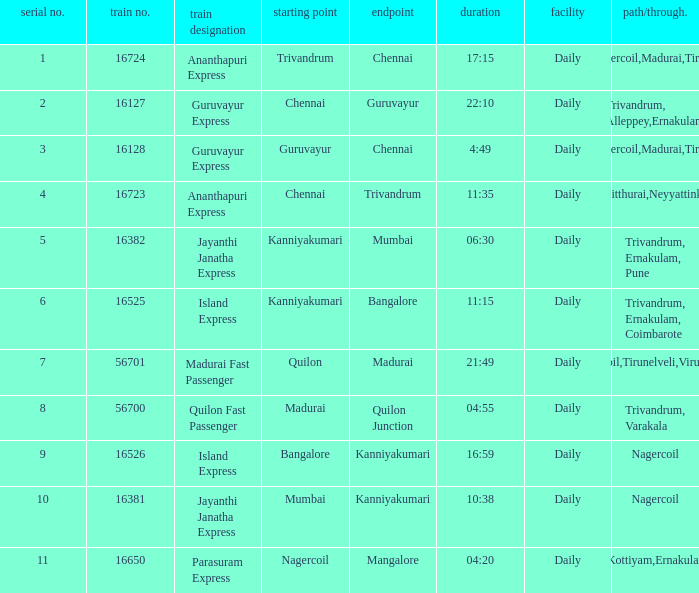What is the destination when the train number is 16526? Kanniyakumari. Parse the table in full. {'header': ['serial no.', 'train no.', 'train designation', 'starting point', 'endpoint', 'duration', 'facility', 'path/through.'], 'rows': [['1', '16724', 'Ananthapuri Express', 'Trivandrum', 'Chennai', '17:15', 'Daily', 'Nagercoil,Madurai,Tiruchi'], ['2', '16127', 'Guruvayur Express', 'Chennai', 'Guruvayur', '22:10', 'Daily', 'Trivandrum, Alleppey,Ernakulam'], ['3', '16128', 'Guruvayur Express', 'Guruvayur', 'Chennai', '4:49', 'Daily', 'Nagercoil,Madurai,Tiruchi'], ['4', '16723', 'Ananthapuri Express', 'Chennai', 'Trivandrum', '11:35', 'Daily', 'Kulitthurai,Neyyattinkara'], ['5', '16382', 'Jayanthi Janatha Express', 'Kanniyakumari', 'Mumbai', '06:30', 'Daily', 'Trivandrum, Ernakulam, Pune'], ['6', '16525', 'Island Express', 'Kanniyakumari', 'Bangalore', '11:15', 'Daily', 'Trivandrum, Ernakulam, Coimbarote'], ['7', '56701', 'Madurai Fast Passenger', 'Quilon', 'Madurai', '21:49', 'Daily', 'Nagercoil,Tirunelveli,Virudunagar'], ['8', '56700', 'Quilon Fast Passenger', 'Madurai', 'Quilon Junction', '04:55', 'Daily', 'Trivandrum, Varakala'], ['9', '16526', 'Island Express', 'Bangalore', 'Kanniyakumari', '16:59', 'Daily', 'Nagercoil'], ['10', '16381', 'Jayanthi Janatha Express', 'Mumbai', 'Kanniyakumari', '10:38', 'Daily', 'Nagercoil'], ['11', '16650', 'Parasuram Express', 'Nagercoil', 'Mangalore', '04:20', 'Daily', 'Trivandrum,Kottiyam,Ernakulam,Kozhikode']]} 